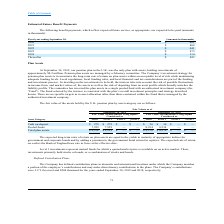According to Csp's financial document, What do Level 1 investments represent? Mutual funds for which a quoted market price is available on an active market. The document states: "Level 1 investments represent mutual funds for which a quoted market price is available on an active market. These..." Also, What is the expected rate of return on cash? The Bank of England base rate in force at the effective date.. The document states: "r equities. The expected rate of return on cash is the Bank of England base rate in force at the effective date...." Also, How is the expected long-term rates of return on plan assets determined? Adding a premium to the government bond return for equities. The document states: "government and corporate bonds and by adding a premium to the government bond return for equities. The expected rate of return on cash is the Bank of ..." Also, can you calculate: What is the difference in the Level 2 and 3 cash on deposit as of September 2019? I cannot find a specific answer to this question in the financial document. Also, can you calculate: What is the the value of the 2019 cash on deposit as a percentage of the total 2019 plan assets?  Based on the calculation: 279/8,238 , the result is 3.39 (percentage). This is based on the information: "Cash on deposit $ 279 $ 279 $ — $ — $ 36 $ 36 $ — $ — Total plan assets $ 8,238 $ 8,238 $ — $ — $ 8,270 $ 8,270 $ — $ —..." The key data points involved are: 279, 8,238. Also, can you calculate: What is the percentage change in the total plan assets between 2018 and 2019? To answer this question, I need to perform calculations using the financial data. The calculation is: ($8,238 - $8,270)/ $8,270 , which equals -0.39 (percentage). This is based on the information: "Total plan assets $ 8,238 $ 8,238 $ — $ — $ 8,270 $ 8,270 $ — $ — Total plan assets $ 8,238 $ 8,238 $ — $ — $ 8,270 $ 8,270 $ — $ —..." The key data points involved are: 8,238, 8,270. 